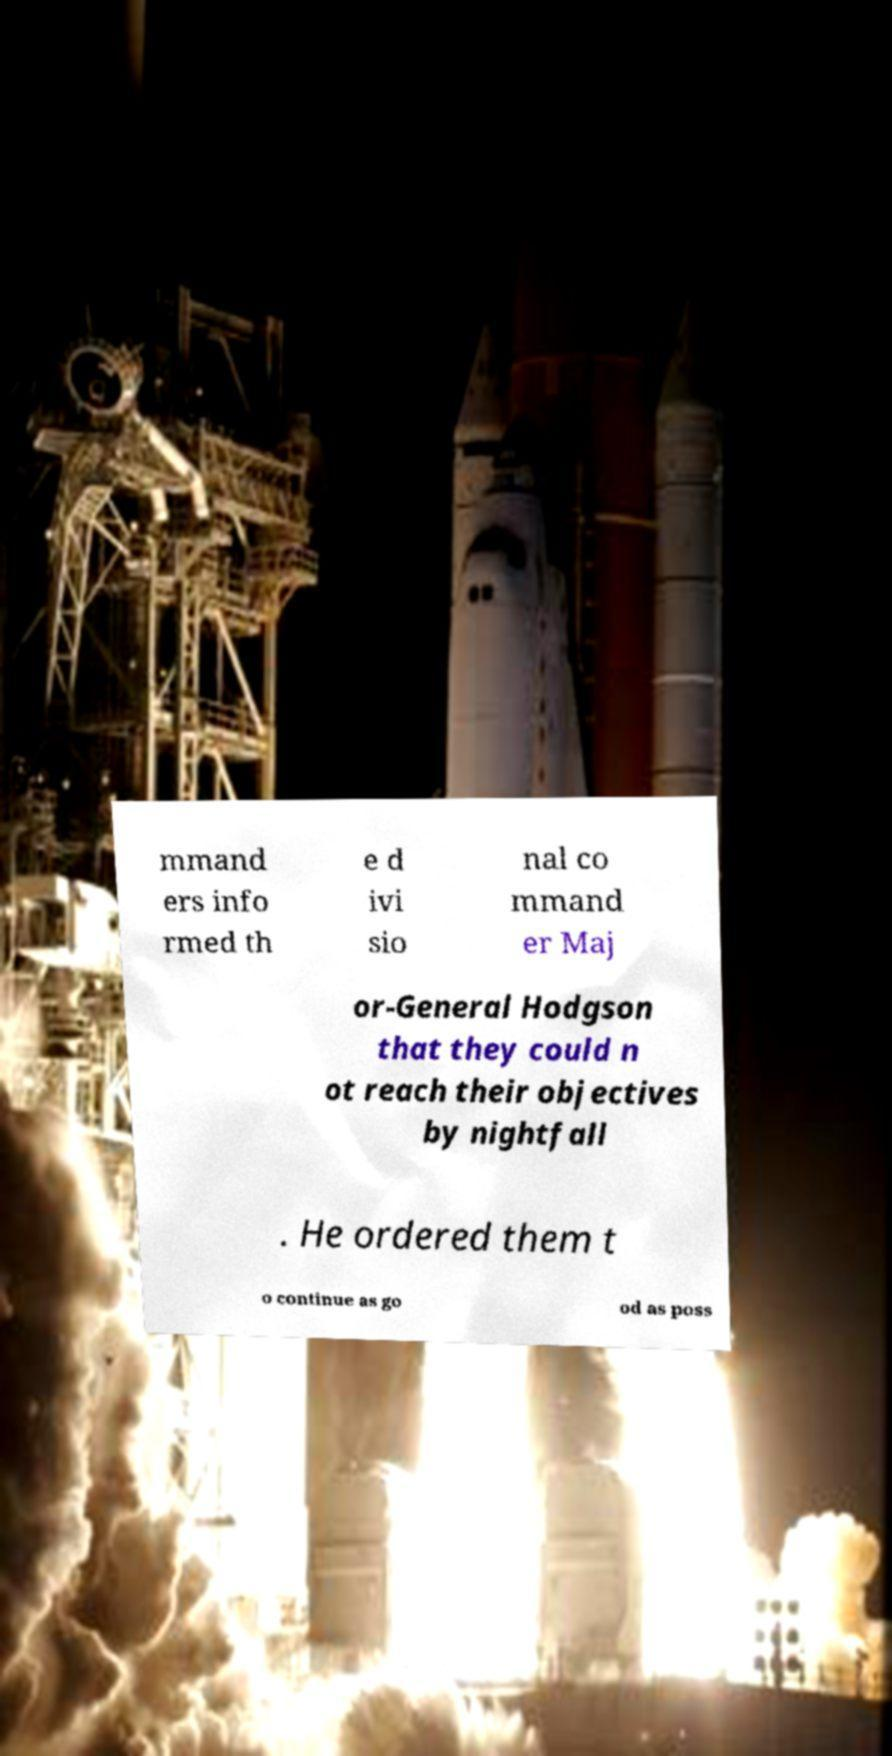For documentation purposes, I need the text within this image transcribed. Could you provide that? mmand ers info rmed th e d ivi sio nal co mmand er Maj or-General Hodgson that they could n ot reach their objectives by nightfall . He ordered them t o continue as go od as poss 